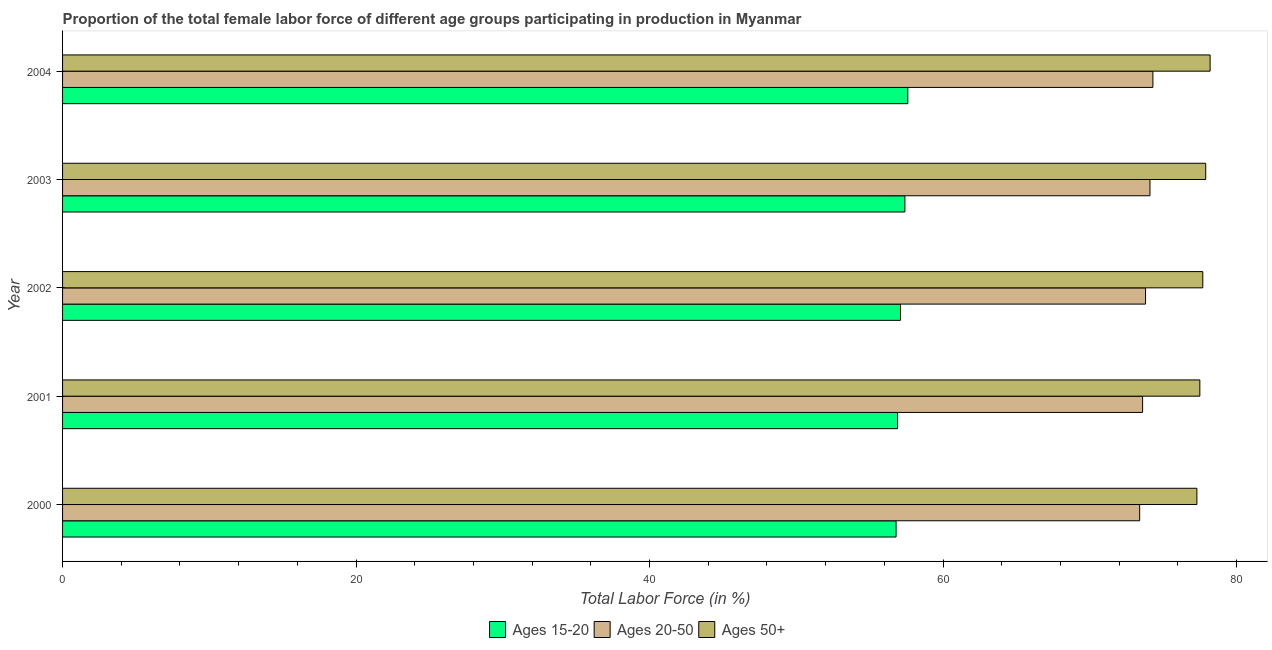Are the number of bars per tick equal to the number of legend labels?
Give a very brief answer. Yes. Are the number of bars on each tick of the Y-axis equal?
Make the answer very short. Yes. How many bars are there on the 5th tick from the top?
Provide a succinct answer. 3. What is the percentage of female labor force within the age group 20-50 in 2002?
Your response must be concise. 73.8. Across all years, what is the maximum percentage of female labor force within the age group 20-50?
Keep it short and to the point. 74.3. Across all years, what is the minimum percentage of female labor force within the age group 15-20?
Give a very brief answer. 56.8. In which year was the percentage of female labor force above age 50 maximum?
Your response must be concise. 2004. In which year was the percentage of female labor force above age 50 minimum?
Ensure brevity in your answer.  2000. What is the total percentage of female labor force within the age group 20-50 in the graph?
Make the answer very short. 369.2. What is the difference between the percentage of female labor force within the age group 20-50 in 2001 and that in 2003?
Give a very brief answer. -0.5. What is the difference between the percentage of female labor force within the age group 15-20 in 2000 and the percentage of female labor force within the age group 20-50 in 2003?
Your response must be concise. -17.3. What is the average percentage of female labor force within the age group 20-50 per year?
Offer a very short reply. 73.84. In the year 2004, what is the difference between the percentage of female labor force above age 50 and percentage of female labor force within the age group 20-50?
Make the answer very short. 3.9. In how many years, is the percentage of female labor force within the age group 20-50 greater than 48 %?
Provide a succinct answer. 5. Is the percentage of female labor force within the age group 20-50 in 2003 less than that in 2004?
Provide a short and direct response. Yes. Is the difference between the percentage of female labor force within the age group 15-20 in 2000 and 2001 greater than the difference between the percentage of female labor force above age 50 in 2000 and 2001?
Offer a very short reply. Yes. What is the difference between the highest and the second highest percentage of female labor force within the age group 15-20?
Your answer should be compact. 0.2. Is the sum of the percentage of female labor force above age 50 in 2000 and 2003 greater than the maximum percentage of female labor force within the age group 15-20 across all years?
Your answer should be compact. Yes. What does the 1st bar from the top in 2000 represents?
Your answer should be compact. Ages 50+. What does the 3rd bar from the bottom in 2004 represents?
Ensure brevity in your answer.  Ages 50+. Is it the case that in every year, the sum of the percentage of female labor force within the age group 15-20 and percentage of female labor force within the age group 20-50 is greater than the percentage of female labor force above age 50?
Make the answer very short. Yes. How many bars are there?
Provide a short and direct response. 15. What is the difference between two consecutive major ticks on the X-axis?
Give a very brief answer. 20. Are the values on the major ticks of X-axis written in scientific E-notation?
Offer a terse response. No. Does the graph contain any zero values?
Offer a very short reply. No. Does the graph contain grids?
Provide a short and direct response. No. How are the legend labels stacked?
Keep it short and to the point. Horizontal. What is the title of the graph?
Make the answer very short. Proportion of the total female labor force of different age groups participating in production in Myanmar. What is the label or title of the X-axis?
Your response must be concise. Total Labor Force (in %). What is the label or title of the Y-axis?
Make the answer very short. Year. What is the Total Labor Force (in %) in Ages 15-20 in 2000?
Your answer should be compact. 56.8. What is the Total Labor Force (in %) of Ages 20-50 in 2000?
Provide a succinct answer. 73.4. What is the Total Labor Force (in %) in Ages 50+ in 2000?
Keep it short and to the point. 77.3. What is the Total Labor Force (in %) of Ages 15-20 in 2001?
Provide a succinct answer. 56.9. What is the Total Labor Force (in %) in Ages 20-50 in 2001?
Offer a terse response. 73.6. What is the Total Labor Force (in %) of Ages 50+ in 2001?
Offer a very short reply. 77.5. What is the Total Labor Force (in %) of Ages 15-20 in 2002?
Offer a terse response. 57.1. What is the Total Labor Force (in %) of Ages 20-50 in 2002?
Make the answer very short. 73.8. What is the Total Labor Force (in %) of Ages 50+ in 2002?
Your response must be concise. 77.7. What is the Total Labor Force (in %) of Ages 15-20 in 2003?
Provide a succinct answer. 57.4. What is the Total Labor Force (in %) of Ages 20-50 in 2003?
Provide a succinct answer. 74.1. What is the Total Labor Force (in %) of Ages 50+ in 2003?
Provide a succinct answer. 77.9. What is the Total Labor Force (in %) of Ages 15-20 in 2004?
Give a very brief answer. 57.6. What is the Total Labor Force (in %) of Ages 20-50 in 2004?
Make the answer very short. 74.3. What is the Total Labor Force (in %) in Ages 50+ in 2004?
Offer a terse response. 78.2. Across all years, what is the maximum Total Labor Force (in %) in Ages 15-20?
Give a very brief answer. 57.6. Across all years, what is the maximum Total Labor Force (in %) of Ages 20-50?
Ensure brevity in your answer.  74.3. Across all years, what is the maximum Total Labor Force (in %) of Ages 50+?
Provide a short and direct response. 78.2. Across all years, what is the minimum Total Labor Force (in %) in Ages 15-20?
Offer a very short reply. 56.8. Across all years, what is the minimum Total Labor Force (in %) of Ages 20-50?
Provide a short and direct response. 73.4. Across all years, what is the minimum Total Labor Force (in %) of Ages 50+?
Provide a succinct answer. 77.3. What is the total Total Labor Force (in %) in Ages 15-20 in the graph?
Make the answer very short. 285.8. What is the total Total Labor Force (in %) in Ages 20-50 in the graph?
Your answer should be very brief. 369.2. What is the total Total Labor Force (in %) of Ages 50+ in the graph?
Offer a very short reply. 388.6. What is the difference between the Total Labor Force (in %) in Ages 50+ in 2000 and that in 2001?
Offer a terse response. -0.2. What is the difference between the Total Labor Force (in %) of Ages 15-20 in 2000 and that in 2002?
Your answer should be very brief. -0.3. What is the difference between the Total Labor Force (in %) of Ages 20-50 in 2000 and that in 2003?
Provide a succinct answer. -0.7. What is the difference between the Total Labor Force (in %) in Ages 50+ in 2000 and that in 2003?
Offer a very short reply. -0.6. What is the difference between the Total Labor Force (in %) in Ages 20-50 in 2000 and that in 2004?
Ensure brevity in your answer.  -0.9. What is the difference between the Total Labor Force (in %) in Ages 50+ in 2000 and that in 2004?
Keep it short and to the point. -0.9. What is the difference between the Total Labor Force (in %) of Ages 50+ in 2001 and that in 2002?
Keep it short and to the point. -0.2. What is the difference between the Total Labor Force (in %) of Ages 50+ in 2001 and that in 2003?
Your answer should be compact. -0.4. What is the difference between the Total Labor Force (in %) in Ages 15-20 in 2001 and that in 2004?
Your response must be concise. -0.7. What is the difference between the Total Labor Force (in %) of Ages 15-20 in 2002 and that in 2003?
Provide a short and direct response. -0.3. What is the difference between the Total Labor Force (in %) of Ages 20-50 in 2002 and that in 2003?
Ensure brevity in your answer.  -0.3. What is the difference between the Total Labor Force (in %) of Ages 15-20 in 2002 and that in 2004?
Offer a terse response. -0.5. What is the difference between the Total Labor Force (in %) of Ages 15-20 in 2003 and that in 2004?
Your response must be concise. -0.2. What is the difference between the Total Labor Force (in %) in Ages 20-50 in 2003 and that in 2004?
Provide a short and direct response. -0.2. What is the difference between the Total Labor Force (in %) in Ages 15-20 in 2000 and the Total Labor Force (in %) in Ages 20-50 in 2001?
Make the answer very short. -16.8. What is the difference between the Total Labor Force (in %) of Ages 15-20 in 2000 and the Total Labor Force (in %) of Ages 50+ in 2001?
Your response must be concise. -20.7. What is the difference between the Total Labor Force (in %) of Ages 20-50 in 2000 and the Total Labor Force (in %) of Ages 50+ in 2001?
Your answer should be compact. -4.1. What is the difference between the Total Labor Force (in %) in Ages 15-20 in 2000 and the Total Labor Force (in %) in Ages 50+ in 2002?
Give a very brief answer. -20.9. What is the difference between the Total Labor Force (in %) in Ages 15-20 in 2000 and the Total Labor Force (in %) in Ages 20-50 in 2003?
Offer a terse response. -17.3. What is the difference between the Total Labor Force (in %) in Ages 15-20 in 2000 and the Total Labor Force (in %) in Ages 50+ in 2003?
Your answer should be compact. -21.1. What is the difference between the Total Labor Force (in %) in Ages 15-20 in 2000 and the Total Labor Force (in %) in Ages 20-50 in 2004?
Offer a very short reply. -17.5. What is the difference between the Total Labor Force (in %) in Ages 15-20 in 2000 and the Total Labor Force (in %) in Ages 50+ in 2004?
Keep it short and to the point. -21.4. What is the difference between the Total Labor Force (in %) in Ages 15-20 in 2001 and the Total Labor Force (in %) in Ages 20-50 in 2002?
Provide a short and direct response. -16.9. What is the difference between the Total Labor Force (in %) of Ages 15-20 in 2001 and the Total Labor Force (in %) of Ages 50+ in 2002?
Ensure brevity in your answer.  -20.8. What is the difference between the Total Labor Force (in %) of Ages 15-20 in 2001 and the Total Labor Force (in %) of Ages 20-50 in 2003?
Your answer should be compact. -17.2. What is the difference between the Total Labor Force (in %) of Ages 15-20 in 2001 and the Total Labor Force (in %) of Ages 20-50 in 2004?
Your answer should be compact. -17.4. What is the difference between the Total Labor Force (in %) of Ages 15-20 in 2001 and the Total Labor Force (in %) of Ages 50+ in 2004?
Your response must be concise. -21.3. What is the difference between the Total Labor Force (in %) of Ages 20-50 in 2001 and the Total Labor Force (in %) of Ages 50+ in 2004?
Make the answer very short. -4.6. What is the difference between the Total Labor Force (in %) in Ages 15-20 in 2002 and the Total Labor Force (in %) in Ages 20-50 in 2003?
Your answer should be compact. -17. What is the difference between the Total Labor Force (in %) in Ages 15-20 in 2002 and the Total Labor Force (in %) in Ages 50+ in 2003?
Offer a very short reply. -20.8. What is the difference between the Total Labor Force (in %) in Ages 15-20 in 2002 and the Total Labor Force (in %) in Ages 20-50 in 2004?
Give a very brief answer. -17.2. What is the difference between the Total Labor Force (in %) in Ages 15-20 in 2002 and the Total Labor Force (in %) in Ages 50+ in 2004?
Provide a short and direct response. -21.1. What is the difference between the Total Labor Force (in %) of Ages 15-20 in 2003 and the Total Labor Force (in %) of Ages 20-50 in 2004?
Your response must be concise. -16.9. What is the difference between the Total Labor Force (in %) of Ages 15-20 in 2003 and the Total Labor Force (in %) of Ages 50+ in 2004?
Provide a succinct answer. -20.8. What is the average Total Labor Force (in %) in Ages 15-20 per year?
Give a very brief answer. 57.16. What is the average Total Labor Force (in %) of Ages 20-50 per year?
Your answer should be compact. 73.84. What is the average Total Labor Force (in %) in Ages 50+ per year?
Make the answer very short. 77.72. In the year 2000, what is the difference between the Total Labor Force (in %) of Ages 15-20 and Total Labor Force (in %) of Ages 20-50?
Provide a succinct answer. -16.6. In the year 2000, what is the difference between the Total Labor Force (in %) in Ages 15-20 and Total Labor Force (in %) in Ages 50+?
Make the answer very short. -20.5. In the year 2000, what is the difference between the Total Labor Force (in %) of Ages 20-50 and Total Labor Force (in %) of Ages 50+?
Your answer should be compact. -3.9. In the year 2001, what is the difference between the Total Labor Force (in %) of Ages 15-20 and Total Labor Force (in %) of Ages 20-50?
Your answer should be compact. -16.7. In the year 2001, what is the difference between the Total Labor Force (in %) in Ages 15-20 and Total Labor Force (in %) in Ages 50+?
Your response must be concise. -20.6. In the year 2001, what is the difference between the Total Labor Force (in %) in Ages 20-50 and Total Labor Force (in %) in Ages 50+?
Your answer should be compact. -3.9. In the year 2002, what is the difference between the Total Labor Force (in %) of Ages 15-20 and Total Labor Force (in %) of Ages 20-50?
Offer a terse response. -16.7. In the year 2002, what is the difference between the Total Labor Force (in %) in Ages 15-20 and Total Labor Force (in %) in Ages 50+?
Keep it short and to the point. -20.6. In the year 2002, what is the difference between the Total Labor Force (in %) in Ages 20-50 and Total Labor Force (in %) in Ages 50+?
Ensure brevity in your answer.  -3.9. In the year 2003, what is the difference between the Total Labor Force (in %) of Ages 15-20 and Total Labor Force (in %) of Ages 20-50?
Provide a succinct answer. -16.7. In the year 2003, what is the difference between the Total Labor Force (in %) of Ages 15-20 and Total Labor Force (in %) of Ages 50+?
Your answer should be compact. -20.5. In the year 2004, what is the difference between the Total Labor Force (in %) in Ages 15-20 and Total Labor Force (in %) in Ages 20-50?
Your response must be concise. -16.7. In the year 2004, what is the difference between the Total Labor Force (in %) of Ages 15-20 and Total Labor Force (in %) of Ages 50+?
Your answer should be compact. -20.6. What is the ratio of the Total Labor Force (in %) of Ages 15-20 in 2000 to that in 2001?
Provide a succinct answer. 1. What is the ratio of the Total Labor Force (in %) in Ages 20-50 in 2000 to that in 2003?
Make the answer very short. 0.99. What is the ratio of the Total Labor Force (in %) in Ages 50+ in 2000 to that in 2003?
Keep it short and to the point. 0.99. What is the ratio of the Total Labor Force (in %) of Ages 15-20 in 2000 to that in 2004?
Your answer should be very brief. 0.99. What is the ratio of the Total Labor Force (in %) in Ages 20-50 in 2000 to that in 2004?
Make the answer very short. 0.99. What is the ratio of the Total Labor Force (in %) of Ages 50+ in 2000 to that in 2004?
Provide a short and direct response. 0.99. What is the ratio of the Total Labor Force (in %) of Ages 20-50 in 2001 to that in 2003?
Give a very brief answer. 0.99. What is the ratio of the Total Labor Force (in %) of Ages 20-50 in 2001 to that in 2004?
Make the answer very short. 0.99. What is the ratio of the Total Labor Force (in %) of Ages 50+ in 2001 to that in 2004?
Your answer should be very brief. 0.99. What is the ratio of the Total Labor Force (in %) in Ages 15-20 in 2002 to that in 2003?
Provide a short and direct response. 0.99. What is the ratio of the Total Labor Force (in %) of Ages 20-50 in 2002 to that in 2003?
Make the answer very short. 1. What is the ratio of the Total Labor Force (in %) of Ages 15-20 in 2002 to that in 2004?
Offer a terse response. 0.99. What is the ratio of the Total Labor Force (in %) in Ages 20-50 in 2002 to that in 2004?
Offer a very short reply. 0.99. What is the ratio of the Total Labor Force (in %) of Ages 15-20 in 2003 to that in 2004?
Offer a very short reply. 1. What is the ratio of the Total Labor Force (in %) of Ages 20-50 in 2003 to that in 2004?
Offer a terse response. 1. What is the difference between the highest and the second highest Total Labor Force (in %) in Ages 50+?
Your response must be concise. 0.3. 